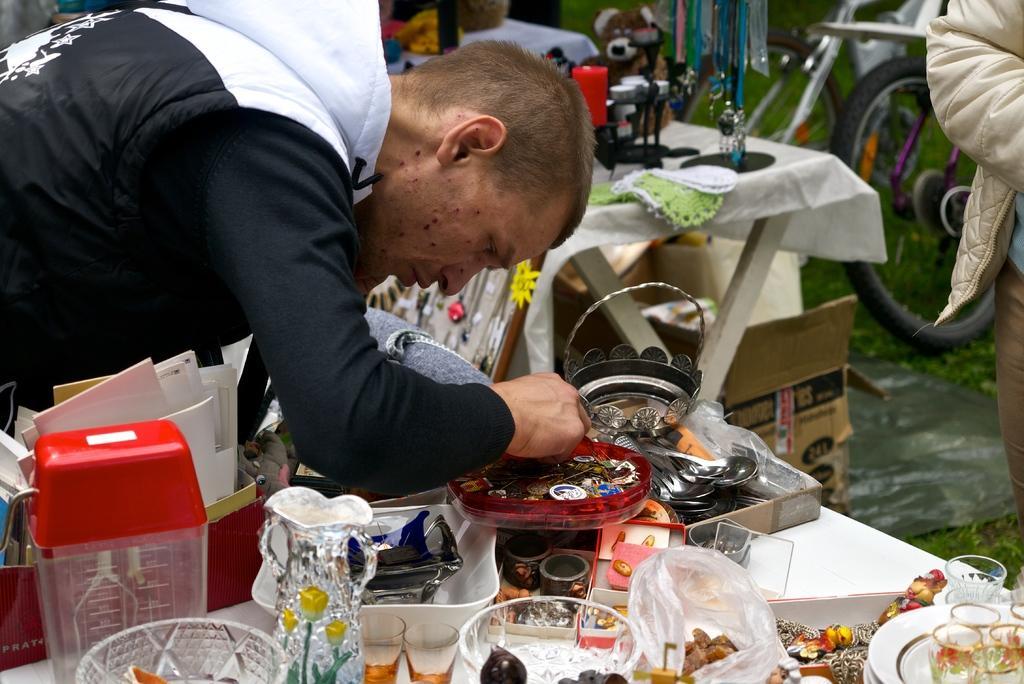Describe this image in one or two sentences. There is a man standing bent and doing something in tray and behind him there are so many thing on table. 